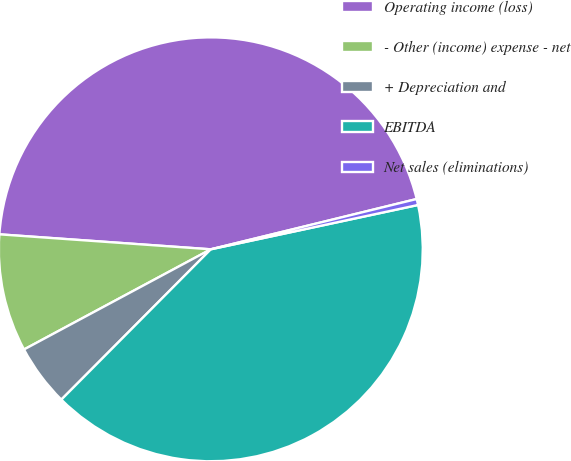<chart> <loc_0><loc_0><loc_500><loc_500><pie_chart><fcel>Operating income (loss)<fcel>- Other (income) expense - net<fcel>+ Depreciation and<fcel>EBITDA<fcel>Net sales (eliminations)<nl><fcel>45.06%<fcel>8.96%<fcel>4.71%<fcel>40.81%<fcel>0.46%<nl></chart> 